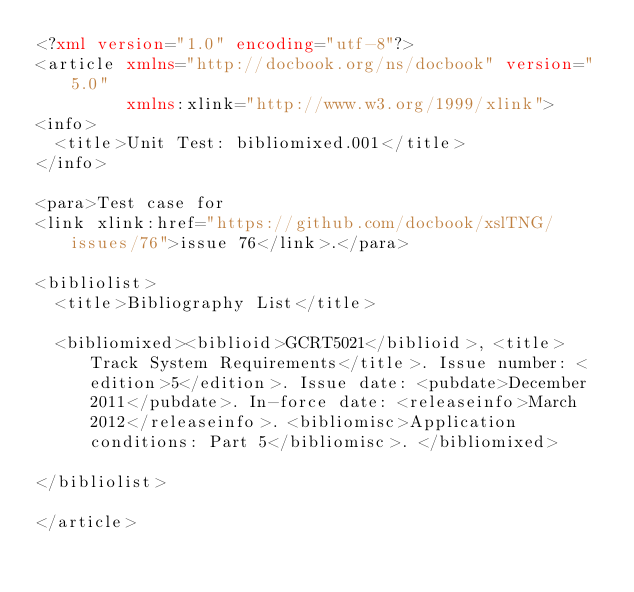<code> <loc_0><loc_0><loc_500><loc_500><_XML_><?xml version="1.0" encoding="utf-8"?>
<article xmlns="http://docbook.org/ns/docbook" version="5.0"
         xmlns:xlink="http://www.w3.org/1999/xlink">
<info>
  <title>Unit Test: bibliomixed.001</title>
</info>

<para>Test case for
<link xlink:href="https://github.com/docbook/xslTNG/issues/76">issue 76</link>.</para>

<bibliolist>
  <title>Bibliography List</title>

  <bibliomixed><biblioid>GCRT5021</biblioid>, <title>Track System Requirements</title>. Issue number: <edition>5</edition>. Issue date: <pubdate>December 2011</pubdate>. In-force date: <releaseinfo>March 2012</releaseinfo>. <bibliomisc>Application conditions: Part 5</bibliomisc>. </bibliomixed>

</bibliolist>

</article>
</code> 